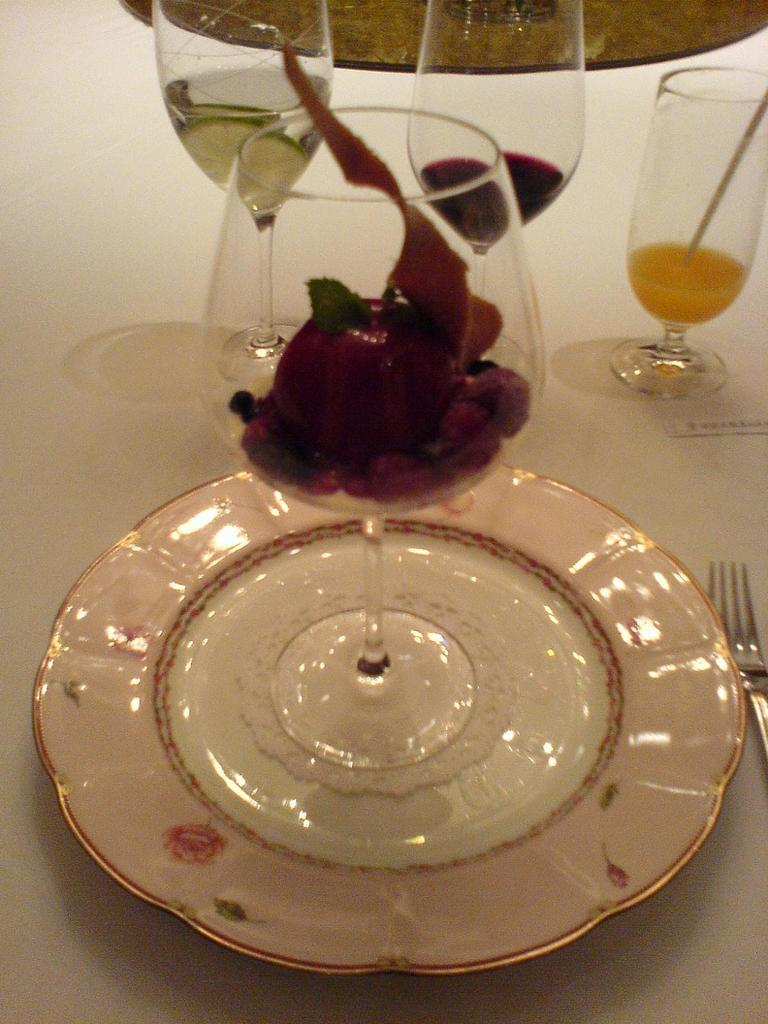What is on the plate in the image? There is a cup of food item on a plate in the image. What utensil is placed beside the plate? A fork is present beside the plate. How many glasses of liquid are visible in the image? There are three glasses of liquid in the image. What type of tank can be seen in the image? There is no tank present in the image. What color are the beans in the image? There are no beans present in the image. 